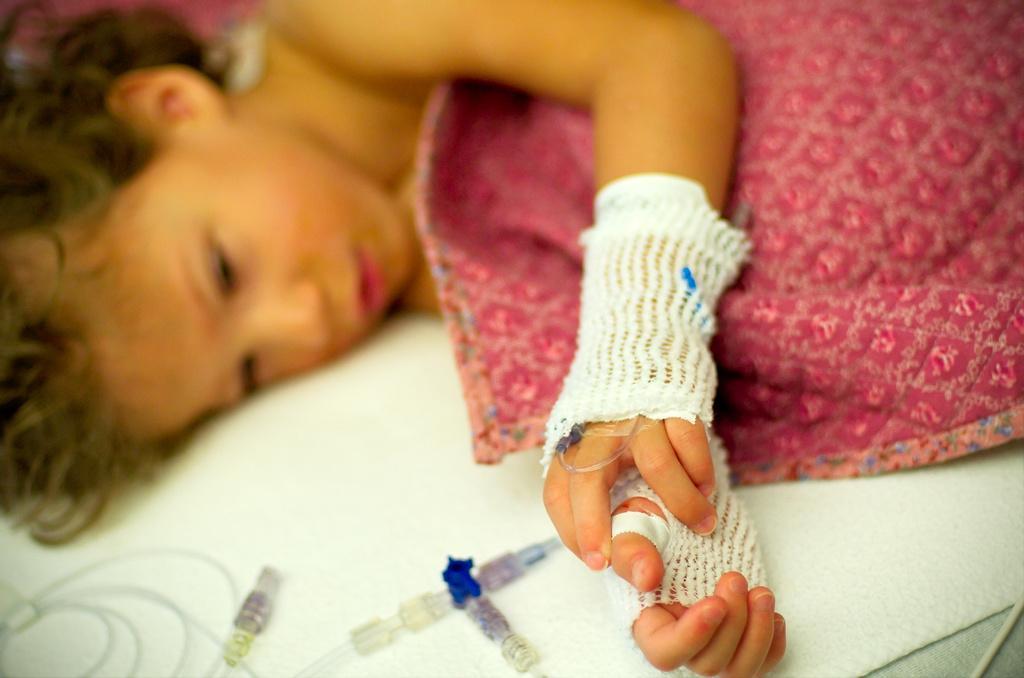Please provide a concise description of this image. In this image we can see a kid lying on the bed with the bandages to the hands. We can also see the blanket. We can see the syringes. 